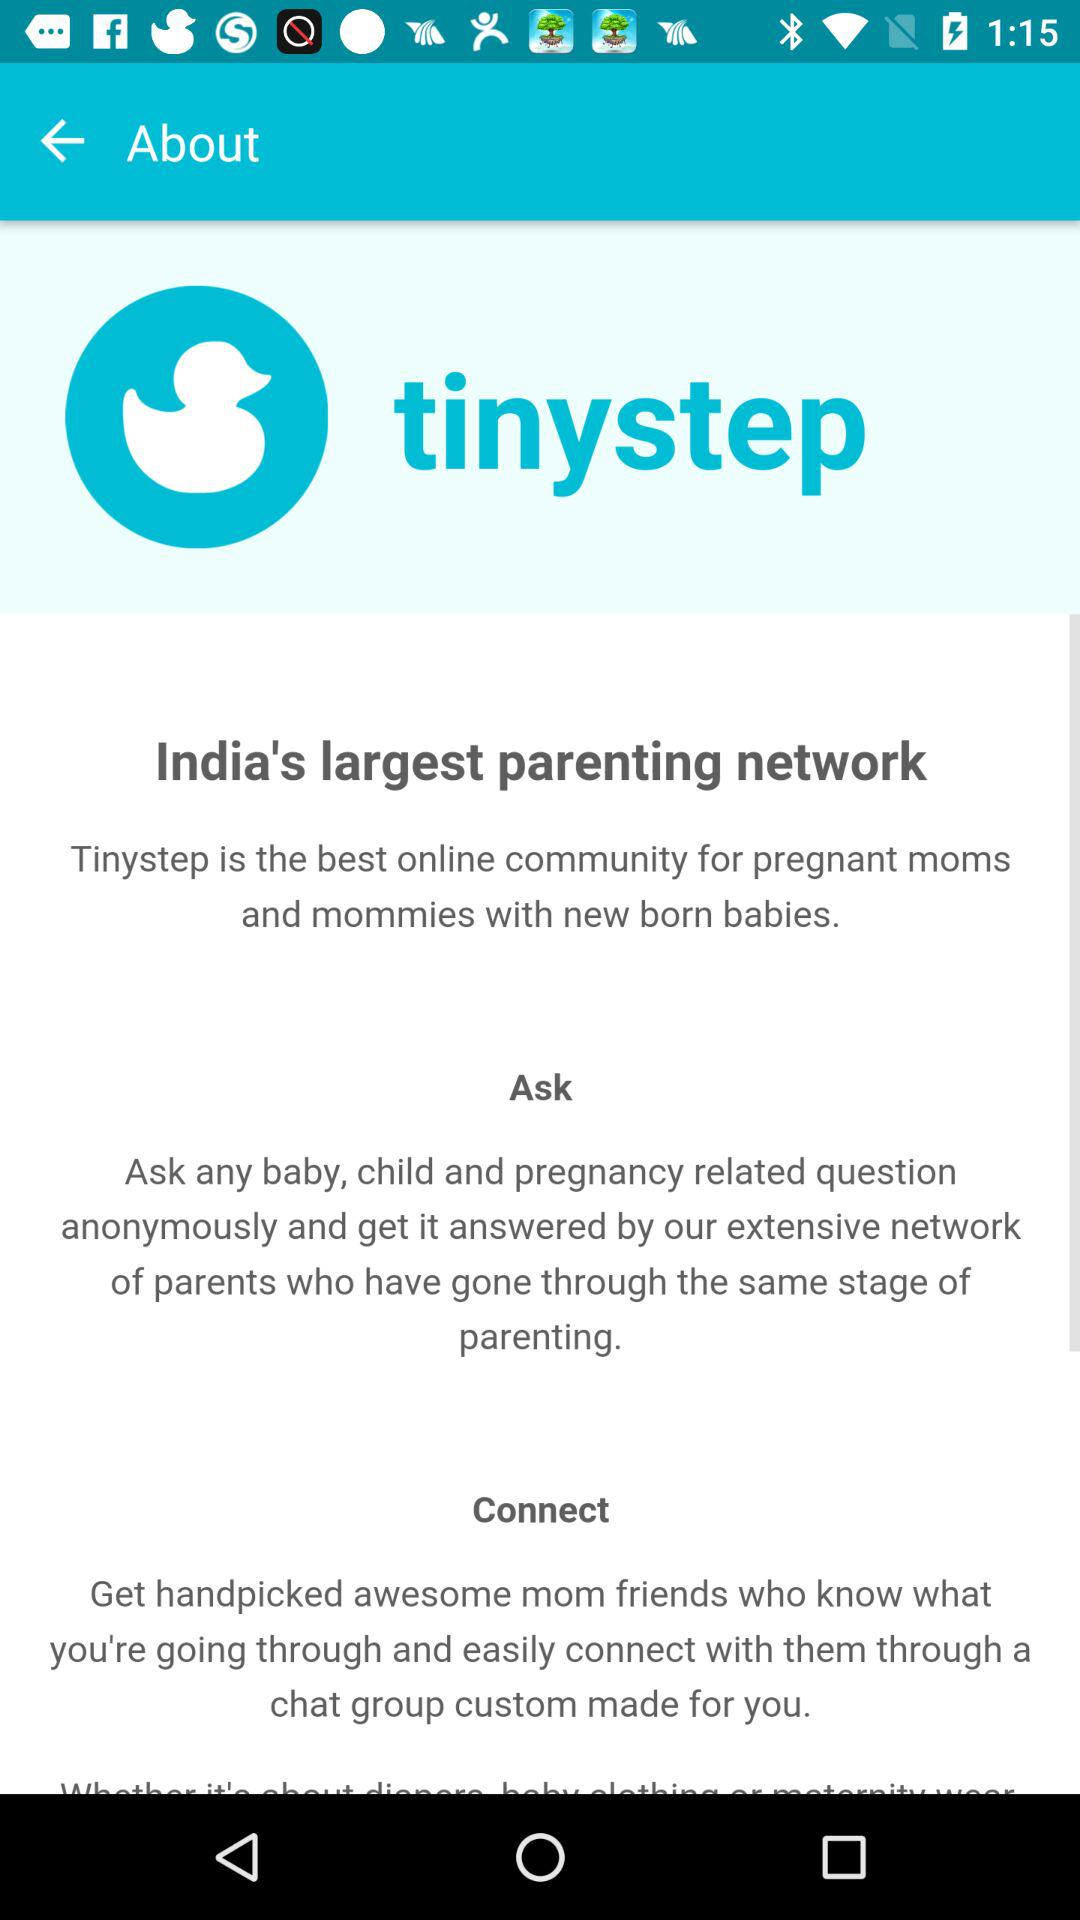What is the application name? The application name is "tinystep". 